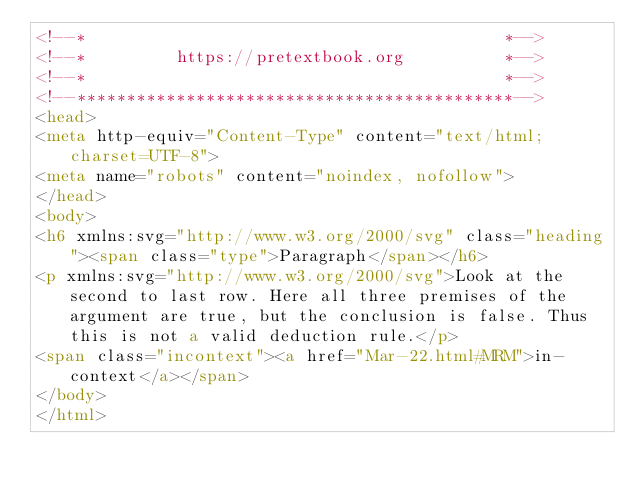Convert code to text. <code><loc_0><loc_0><loc_500><loc_500><_HTML_><!--*                                          *-->
<!--*         https://pretextbook.org          *-->
<!--*                                          *-->
<!--********************************************-->
<head>
<meta http-equiv="Content-Type" content="text/html; charset=UTF-8">
<meta name="robots" content="noindex, nofollow">
</head>
<body>
<h6 xmlns:svg="http://www.w3.org/2000/svg" class="heading"><span class="type">Paragraph</span></h6>
<p xmlns:svg="http://www.w3.org/2000/svg">Look at the second to last row. Here all three premises of the argument are true, but the conclusion is false. Thus this is not a valid deduction rule.</p>
<span class="incontext"><a href="Mar-22.html#MRM">in-context</a></span>
</body>
</html>
</code> 